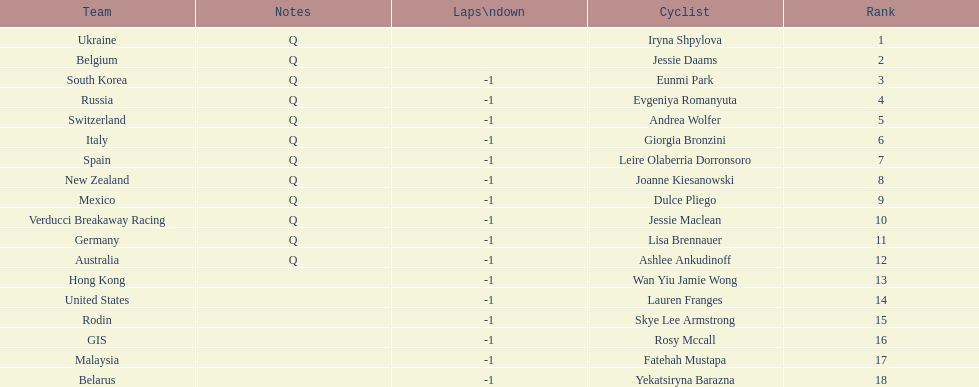Can you parse all the data within this table? {'header': ['Team', 'Notes', 'Laps\\ndown', 'Cyclist', 'Rank'], 'rows': [['Ukraine', 'Q', '', 'Iryna Shpylova', '1'], ['Belgium', 'Q', '', 'Jessie Daams', '2'], ['South Korea', 'Q', '-1', 'Eunmi Park', '3'], ['Russia', 'Q', '-1', 'Evgeniya Romanyuta', '4'], ['Switzerland', 'Q', '-1', 'Andrea Wolfer', '5'], ['Italy', 'Q', '-1', 'Giorgia Bronzini', '6'], ['Spain', 'Q', '-1', 'Leire Olaberria Dorronsoro', '7'], ['New Zealand', 'Q', '-1', 'Joanne Kiesanowski', '8'], ['Mexico', 'Q', '-1', 'Dulce Pliego', '9'], ['Verducci Breakaway Racing', 'Q', '-1', 'Jessie Maclean', '10'], ['Germany', 'Q', '-1', 'Lisa Brennauer', '11'], ['Australia', 'Q', '-1', 'Ashlee Ankudinoff', '12'], ['Hong Kong', '', '-1', 'Wan Yiu Jamie Wong', '13'], ['United States', '', '-1', 'Lauren Franges', '14'], ['Rodin', '', '-1', 'Skye Lee Armstrong', '15'], ['GIS', '', '-1', 'Rosy Mccall', '16'], ['Malaysia', '', '-1', 'Fatehah Mustapa', '17'], ['Belarus', '', '-1', 'Yekatsiryna Barazna', '18']]} What two cyclists come from teams with no laps down? Iryna Shpylova, Jessie Daams. 